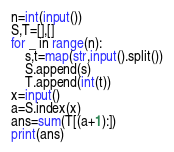Convert code to text. <code><loc_0><loc_0><loc_500><loc_500><_Python_>n=int(input())
S,T=[],[]
for _ in range(n):
    s,t=map(str,input().split())
    S.append(s)
    T.append(int(t))
x=input()
a=S.index(x)
ans=sum(T[(a+1):])
print(ans)</code> 